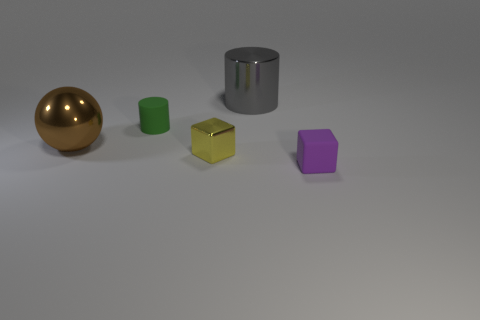Add 3 yellow metal objects. How many objects exist? 8 Subtract all blocks. How many objects are left? 3 Add 3 tiny matte cylinders. How many tiny matte cylinders are left? 4 Add 4 cylinders. How many cylinders exist? 6 Subtract 1 purple cubes. How many objects are left? 4 Subtract all large yellow matte objects. Subtract all big brown shiny objects. How many objects are left? 4 